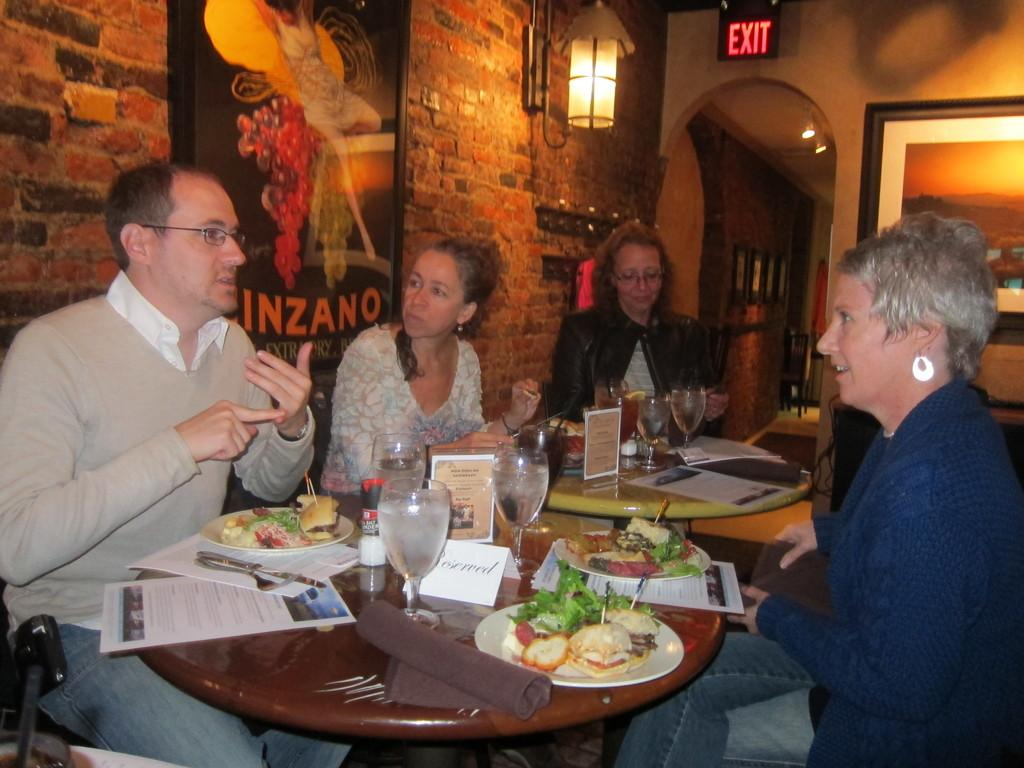What type of structure can be seen in the image? There is a brick wall in the image. What is hanging in the image? There is a banner in the image. What can be used for illumination in the image? There is a light in the image. What are the people in the image doing? The people are sitting on chairs in the image. What is on the table in the image? There is a table in the image with plates, glasses, and papers on it. What position does the bird take in the image? There is no bird present in the image. What type of shock can be seen in the image? There is no shock present in the image. 